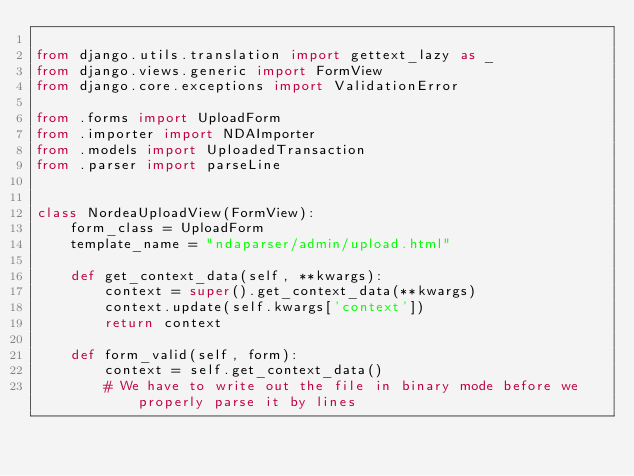Convert code to text. <code><loc_0><loc_0><loc_500><loc_500><_Python_>
from django.utils.translation import gettext_lazy as _
from django.views.generic import FormView
from django.core.exceptions import ValidationError

from .forms import UploadForm
from .importer import NDAImporter
from .models import UploadedTransaction
from .parser import parseLine


class NordeaUploadView(FormView):
    form_class = UploadForm
    template_name = "ndaparser/admin/upload.html"

    def get_context_data(self, **kwargs):
        context = super().get_context_data(**kwargs)
        context.update(self.kwargs['context'])
        return context

    def form_valid(self, form):
        context = self.get_context_data()
        # We have to write out the file in binary mode before we properly parse it by lines</code> 